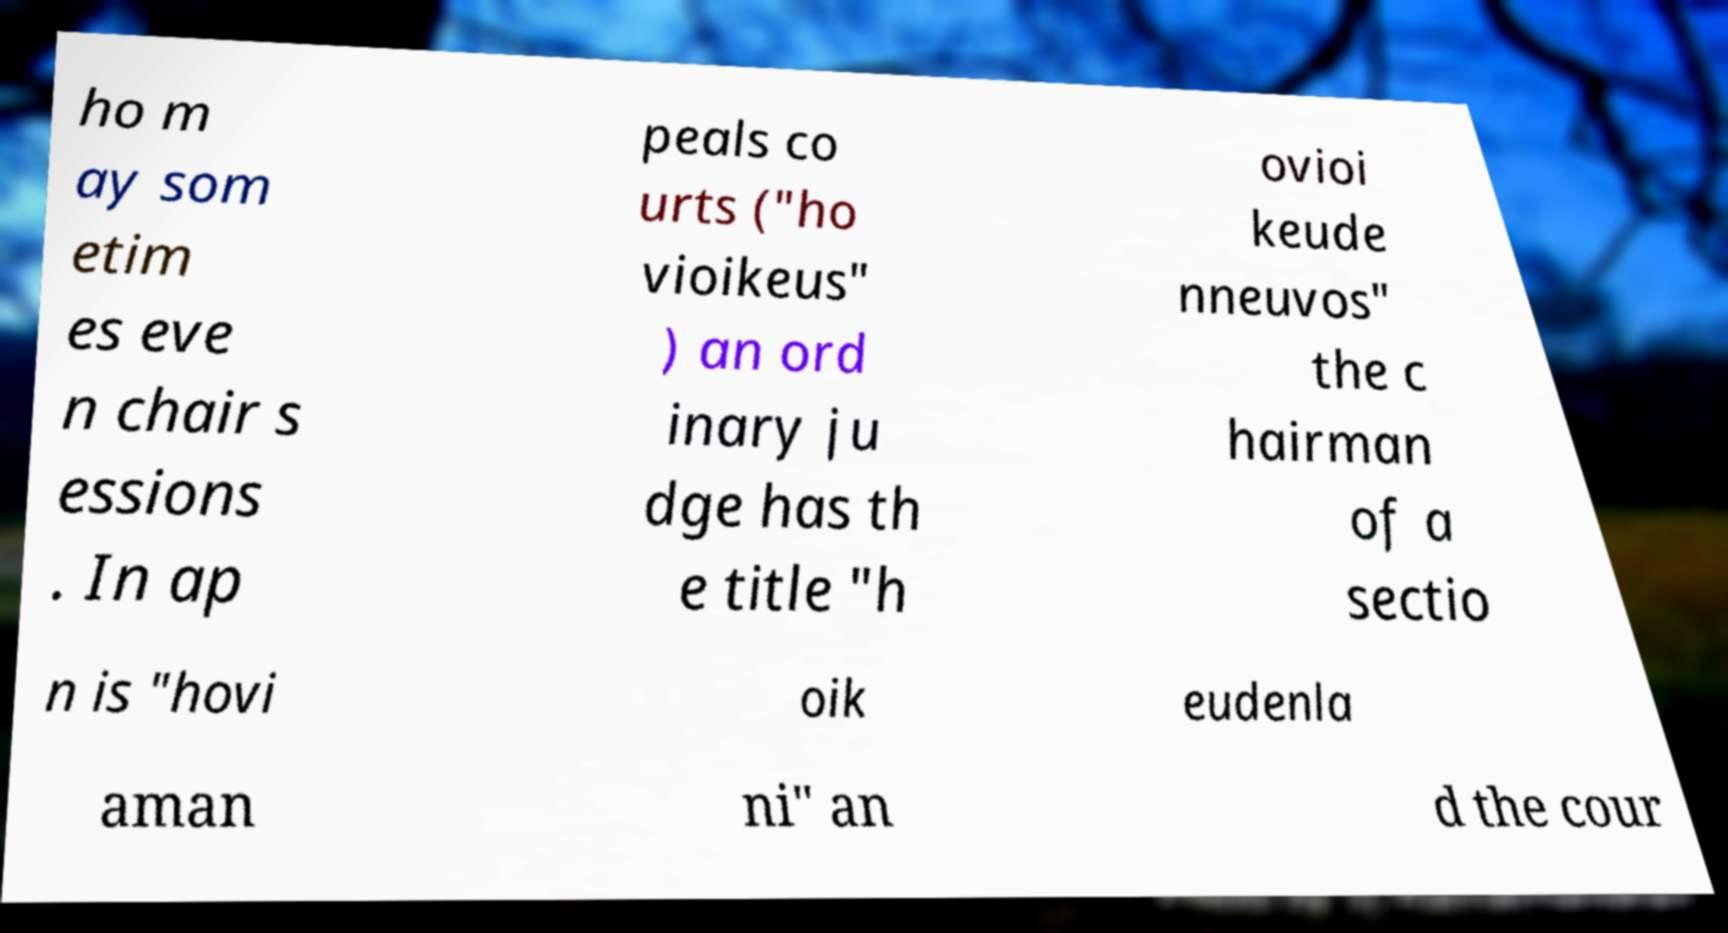What messages or text are displayed in this image? I need them in a readable, typed format. ho m ay som etim es eve n chair s essions . In ap peals co urts ("ho vioikeus" ) an ord inary ju dge has th e title "h ovioi keude nneuvos" the c hairman of a sectio n is "hovi oik eudenla aman ni" an d the cour 